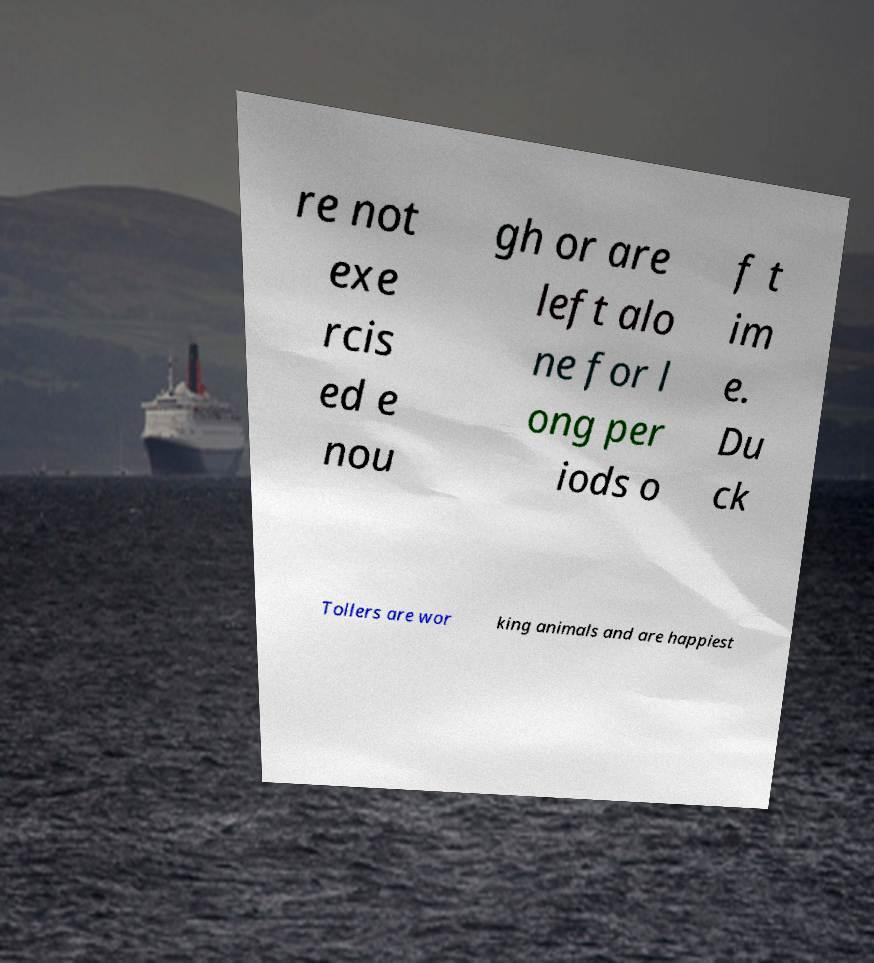Could you extract and type out the text from this image? re not exe rcis ed e nou gh or are left alo ne for l ong per iods o f t im e. Du ck Tollers are wor king animals and are happiest 